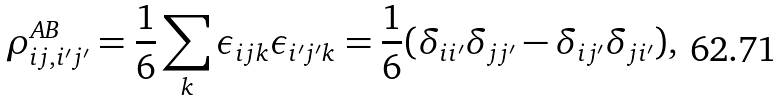<formula> <loc_0><loc_0><loc_500><loc_500>\rho ^ { A B } _ { i j , i ^ { \prime } j ^ { \prime } } = \frac { 1 } { 6 } \sum _ { k } \epsilon _ { i j k } \epsilon _ { i ^ { \prime } j ^ { \prime } k } = \frac { 1 } { 6 } ( \delta _ { i i ^ { \prime } } \delta _ { j j ^ { \prime } } - \delta _ { i j ^ { \prime } } \delta _ { j i ^ { \prime } } ) ,</formula> 